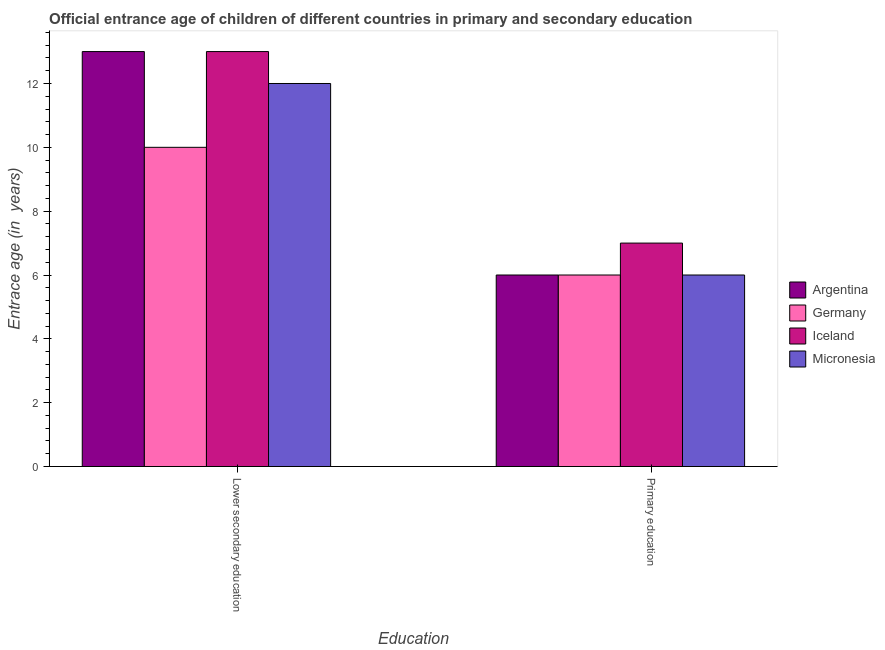How many different coloured bars are there?
Make the answer very short. 4. How many groups of bars are there?
Provide a short and direct response. 2. Are the number of bars per tick equal to the number of legend labels?
Offer a very short reply. Yes. Are the number of bars on each tick of the X-axis equal?
Your answer should be very brief. Yes. What is the label of the 1st group of bars from the left?
Provide a succinct answer. Lower secondary education. Across all countries, what is the maximum entrance age of children in lower secondary education?
Make the answer very short. 13. Across all countries, what is the minimum entrance age of chiildren in primary education?
Make the answer very short. 6. In which country was the entrance age of children in lower secondary education minimum?
Offer a terse response. Germany. What is the total entrance age of chiildren in primary education in the graph?
Keep it short and to the point. 25. What is the difference between the entrance age of children in lower secondary education in Iceland and that in Argentina?
Offer a terse response. 0. What is the difference between the entrance age of chiildren in primary education in Micronesia and the entrance age of children in lower secondary education in Germany?
Ensure brevity in your answer.  -4. What is the average entrance age of chiildren in primary education per country?
Make the answer very short. 6.25. What is the difference between the entrance age of children in lower secondary education and entrance age of chiildren in primary education in Argentina?
Provide a succinct answer. 7. In how many countries, is the entrance age of children in lower secondary education greater than 10.8 years?
Your answer should be very brief. 3. Is the entrance age of children in lower secondary education in Iceland less than that in Argentina?
Your response must be concise. No. In how many countries, is the entrance age of children in lower secondary education greater than the average entrance age of children in lower secondary education taken over all countries?
Your answer should be very brief. 2. What does the 4th bar from the left in Lower secondary education represents?
Provide a succinct answer. Micronesia. How many bars are there?
Offer a terse response. 8. How many countries are there in the graph?
Your answer should be compact. 4. What is the difference between two consecutive major ticks on the Y-axis?
Your response must be concise. 2. Are the values on the major ticks of Y-axis written in scientific E-notation?
Offer a very short reply. No. Does the graph contain any zero values?
Offer a very short reply. No. How are the legend labels stacked?
Your answer should be compact. Vertical. What is the title of the graph?
Give a very brief answer. Official entrance age of children of different countries in primary and secondary education. Does "Colombia" appear as one of the legend labels in the graph?
Provide a short and direct response. No. What is the label or title of the X-axis?
Provide a succinct answer. Education. What is the label or title of the Y-axis?
Offer a very short reply. Entrace age (in  years). What is the Entrace age (in  years) of Germany in Lower secondary education?
Provide a succinct answer. 10. What is the Entrace age (in  years) in Iceland in Lower secondary education?
Ensure brevity in your answer.  13. What is the Entrace age (in  years) of Argentina in Primary education?
Keep it short and to the point. 6. What is the Entrace age (in  years) in Germany in Primary education?
Provide a short and direct response. 6. What is the Entrace age (in  years) in Micronesia in Primary education?
Keep it short and to the point. 6. Across all Education, what is the maximum Entrace age (in  years) in Argentina?
Offer a terse response. 13. Across all Education, what is the maximum Entrace age (in  years) of Iceland?
Provide a succinct answer. 13. Across all Education, what is the minimum Entrace age (in  years) in Argentina?
Offer a terse response. 6. Across all Education, what is the minimum Entrace age (in  years) in Germany?
Provide a short and direct response. 6. Across all Education, what is the minimum Entrace age (in  years) of Iceland?
Offer a very short reply. 7. What is the total Entrace age (in  years) in Argentina in the graph?
Keep it short and to the point. 19. What is the total Entrace age (in  years) in Germany in the graph?
Offer a terse response. 16. What is the total Entrace age (in  years) in Iceland in the graph?
Your response must be concise. 20. What is the difference between the Entrace age (in  years) in Argentina in Lower secondary education and that in Primary education?
Make the answer very short. 7. What is the difference between the Entrace age (in  years) of Germany in Lower secondary education and that in Primary education?
Provide a short and direct response. 4. What is the difference between the Entrace age (in  years) of Iceland in Lower secondary education and that in Primary education?
Ensure brevity in your answer.  6. What is the difference between the Entrace age (in  years) in Argentina in Lower secondary education and the Entrace age (in  years) in Iceland in Primary education?
Keep it short and to the point. 6. What is the difference between the Entrace age (in  years) of Germany in Lower secondary education and the Entrace age (in  years) of Iceland in Primary education?
Your answer should be very brief. 3. What is the difference between the Entrace age (in  years) in Iceland in Lower secondary education and the Entrace age (in  years) in Micronesia in Primary education?
Your response must be concise. 7. What is the average Entrace age (in  years) of Germany per Education?
Keep it short and to the point. 8. What is the average Entrace age (in  years) of Iceland per Education?
Your response must be concise. 10. What is the difference between the Entrace age (in  years) of Argentina and Entrace age (in  years) of Germany in Lower secondary education?
Provide a short and direct response. 3. What is the difference between the Entrace age (in  years) in Argentina and Entrace age (in  years) in Iceland in Lower secondary education?
Ensure brevity in your answer.  0. What is the difference between the Entrace age (in  years) of Germany and Entrace age (in  years) of Micronesia in Lower secondary education?
Make the answer very short. -2. What is the difference between the Entrace age (in  years) of Iceland and Entrace age (in  years) of Micronesia in Lower secondary education?
Make the answer very short. 1. What is the difference between the Entrace age (in  years) in Argentina and Entrace age (in  years) in Iceland in Primary education?
Offer a very short reply. -1. What is the ratio of the Entrace age (in  years) of Argentina in Lower secondary education to that in Primary education?
Offer a terse response. 2.17. What is the ratio of the Entrace age (in  years) in Iceland in Lower secondary education to that in Primary education?
Your answer should be very brief. 1.86. What is the ratio of the Entrace age (in  years) in Micronesia in Lower secondary education to that in Primary education?
Your response must be concise. 2. What is the difference between the highest and the second highest Entrace age (in  years) in Argentina?
Keep it short and to the point. 7. What is the difference between the highest and the lowest Entrace age (in  years) in Argentina?
Your response must be concise. 7. What is the difference between the highest and the lowest Entrace age (in  years) of Micronesia?
Your response must be concise. 6. 